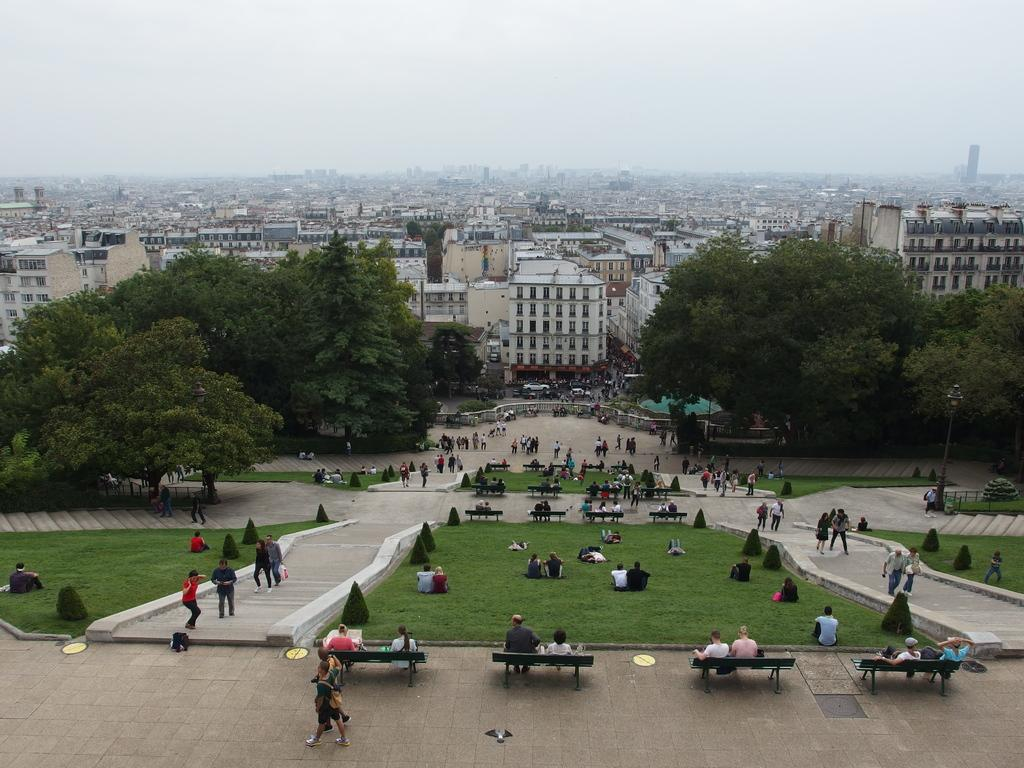How many people are in the image? There is a group of people in the image. What are some of the people in the image doing? Some people are standing, some are sitting, and some are walking. What can be seen in the background of the image? There are buildings, trees, and the sky visible in the background of the image. What type of toys can be seen in the hands of the boy in the image? There is no boy present in the image, and therefore no toys can be seen in his hands. 